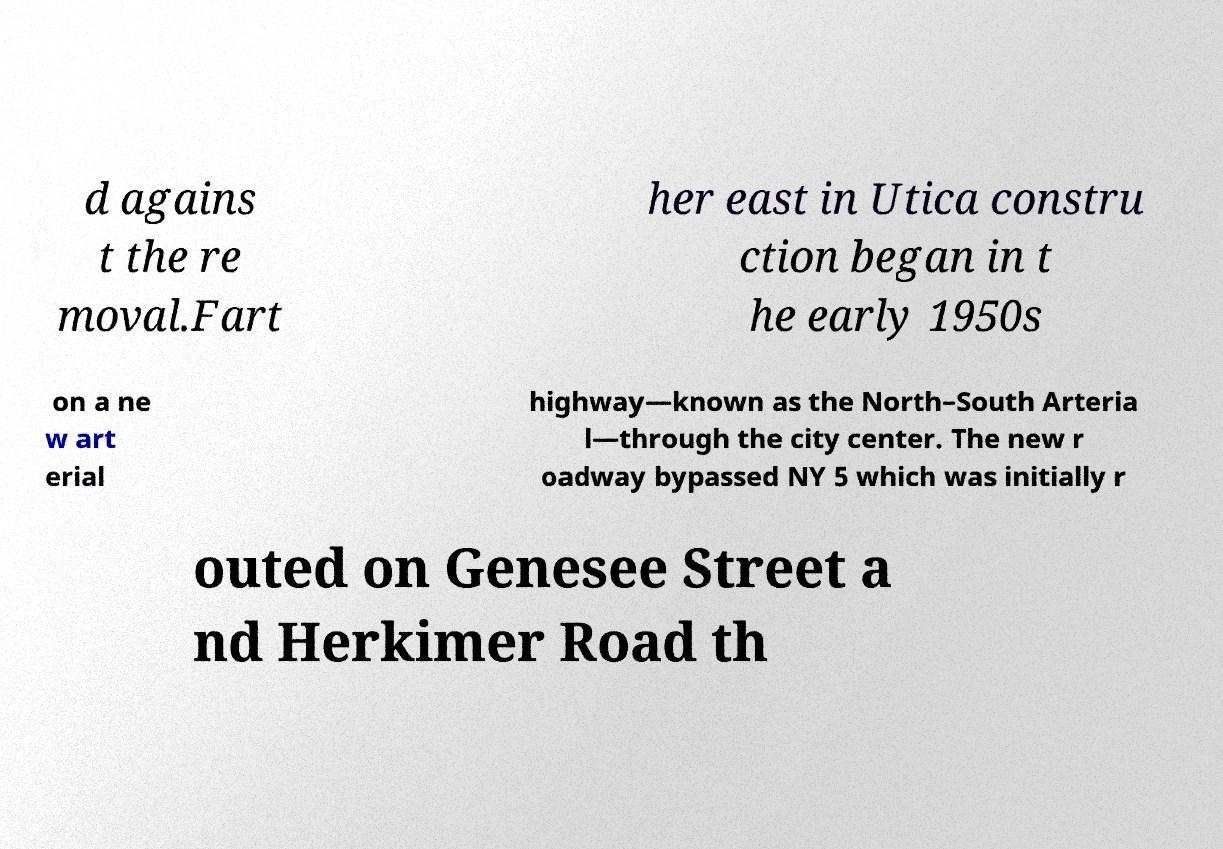I need the written content from this picture converted into text. Can you do that? d agains t the re moval.Fart her east in Utica constru ction began in t he early 1950s on a ne w art erial highway—known as the North–South Arteria l—through the city center. The new r oadway bypassed NY 5 which was initially r outed on Genesee Street a nd Herkimer Road th 